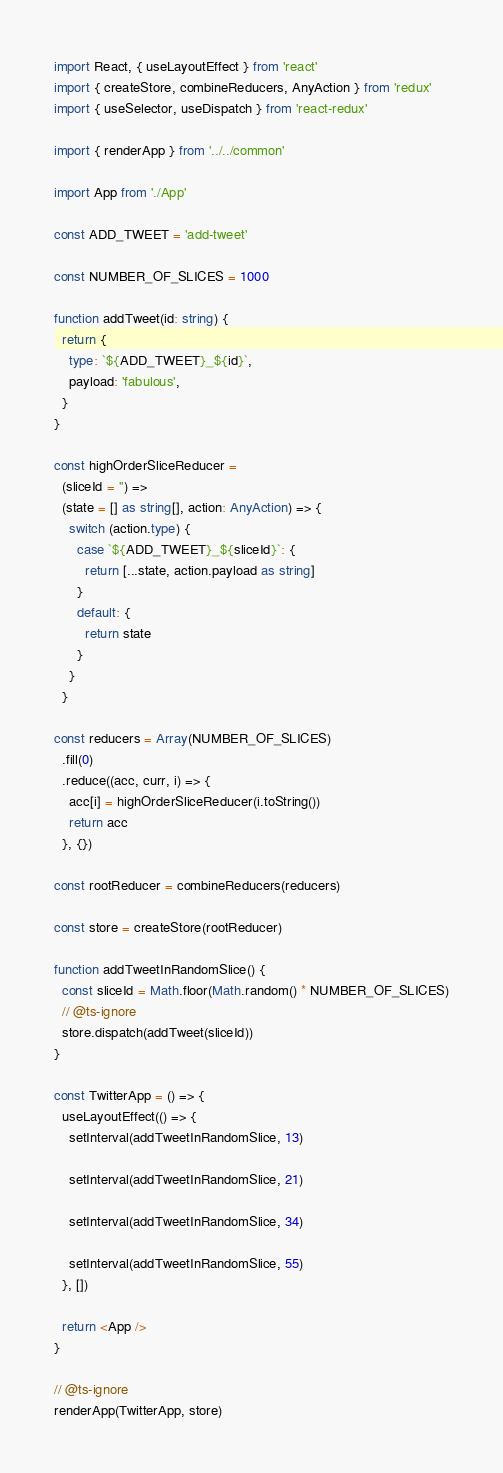<code> <loc_0><loc_0><loc_500><loc_500><_TypeScript_>import React, { useLayoutEffect } from 'react'
import { createStore, combineReducers, AnyAction } from 'redux'
import { useSelector, useDispatch } from 'react-redux'

import { renderApp } from '../../common'

import App from './App'

const ADD_TWEET = 'add-tweet'

const NUMBER_OF_SLICES = 1000

function addTweet(id: string) {
  return {
    type: `${ADD_TWEET}_${id}`,
    payload: 'fabulous',
  }
}

const highOrderSliceReducer =
  (sliceId = '') =>
  (state = [] as string[], action: AnyAction) => {
    switch (action.type) {
      case `${ADD_TWEET}_${sliceId}`: {
        return [...state, action.payload as string]
      }
      default: {
        return state
      }
    }
  }

const reducers = Array(NUMBER_OF_SLICES)
  .fill(0)
  .reduce((acc, curr, i) => {
    acc[i] = highOrderSliceReducer(i.toString())
    return acc
  }, {})

const rootReducer = combineReducers(reducers)

const store = createStore(rootReducer)

function addTweetInRandomSlice() {
  const sliceId = Math.floor(Math.random() * NUMBER_OF_SLICES)
  // @ts-ignore
  store.dispatch(addTweet(sliceId))
}

const TwitterApp = () => {
  useLayoutEffect(() => {
    setInterval(addTweetInRandomSlice, 13)

    setInterval(addTweetInRandomSlice, 21)

    setInterval(addTweetInRandomSlice, 34)

    setInterval(addTweetInRandomSlice, 55)
  }, [])

  return <App />
}

// @ts-ignore
renderApp(TwitterApp, store)
</code> 